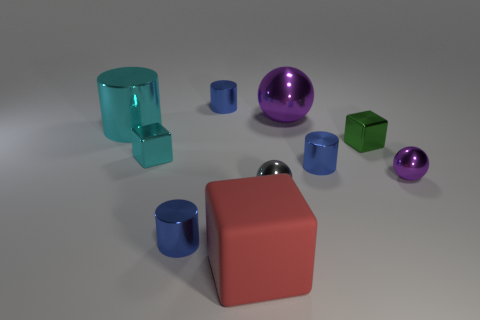How many total objects are there in the image, and can you describe their colors? In total, the image showcases eight distinct objects. There are two objects with a hue of transparent teal, three with a reflective purple, two featuring a metallic silver, and finally one object that possesses a matte coral tint. 